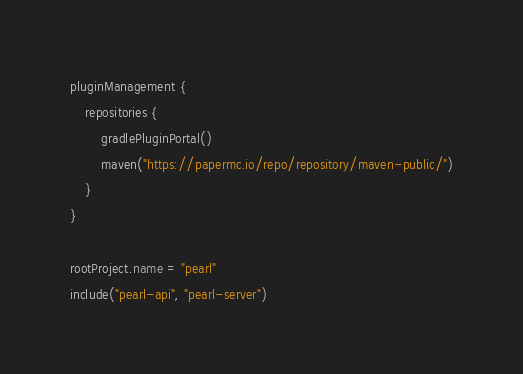Convert code to text. <code><loc_0><loc_0><loc_500><loc_500><_Kotlin_>pluginManagement {
    repositories {
        gradlePluginPortal()
        maven("https://papermc.io/repo/repository/maven-public/")
    }
}

rootProject.name = "pearl"
include("pearl-api", "pearl-server")</code> 